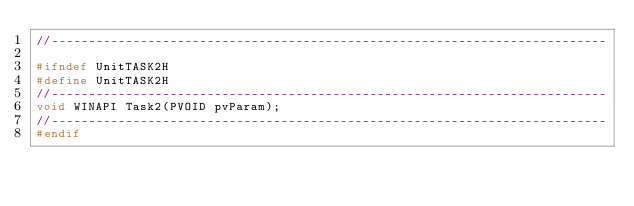Convert code to text. <code><loc_0><loc_0><loc_500><loc_500><_C_>//---------------------------------------------------------------------------

#ifndef UnitTASK2H
#define UnitTASK2H
//---------------------------------------------------------------------------
void WINAPI Task2(PVOID pvParam);
//---------------------------------------------------------------------------
#endif
</code> 